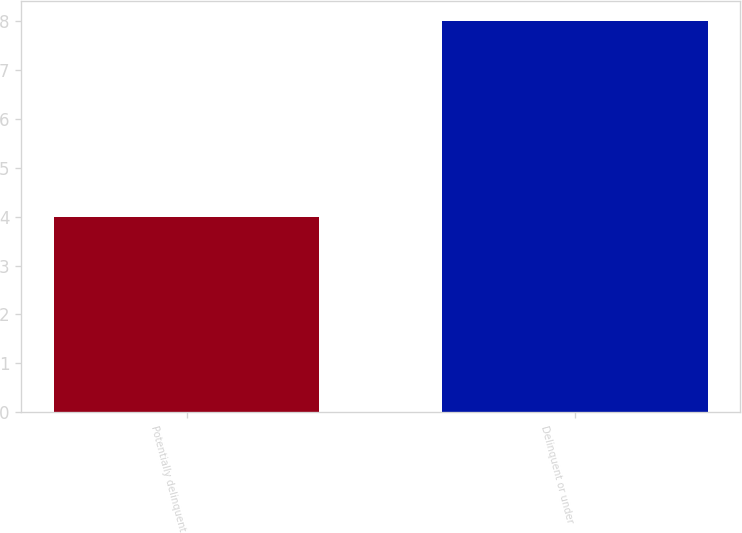<chart> <loc_0><loc_0><loc_500><loc_500><bar_chart><fcel>Potentially delinquent<fcel>Delinquent or under<nl><fcel>4<fcel>8<nl></chart> 